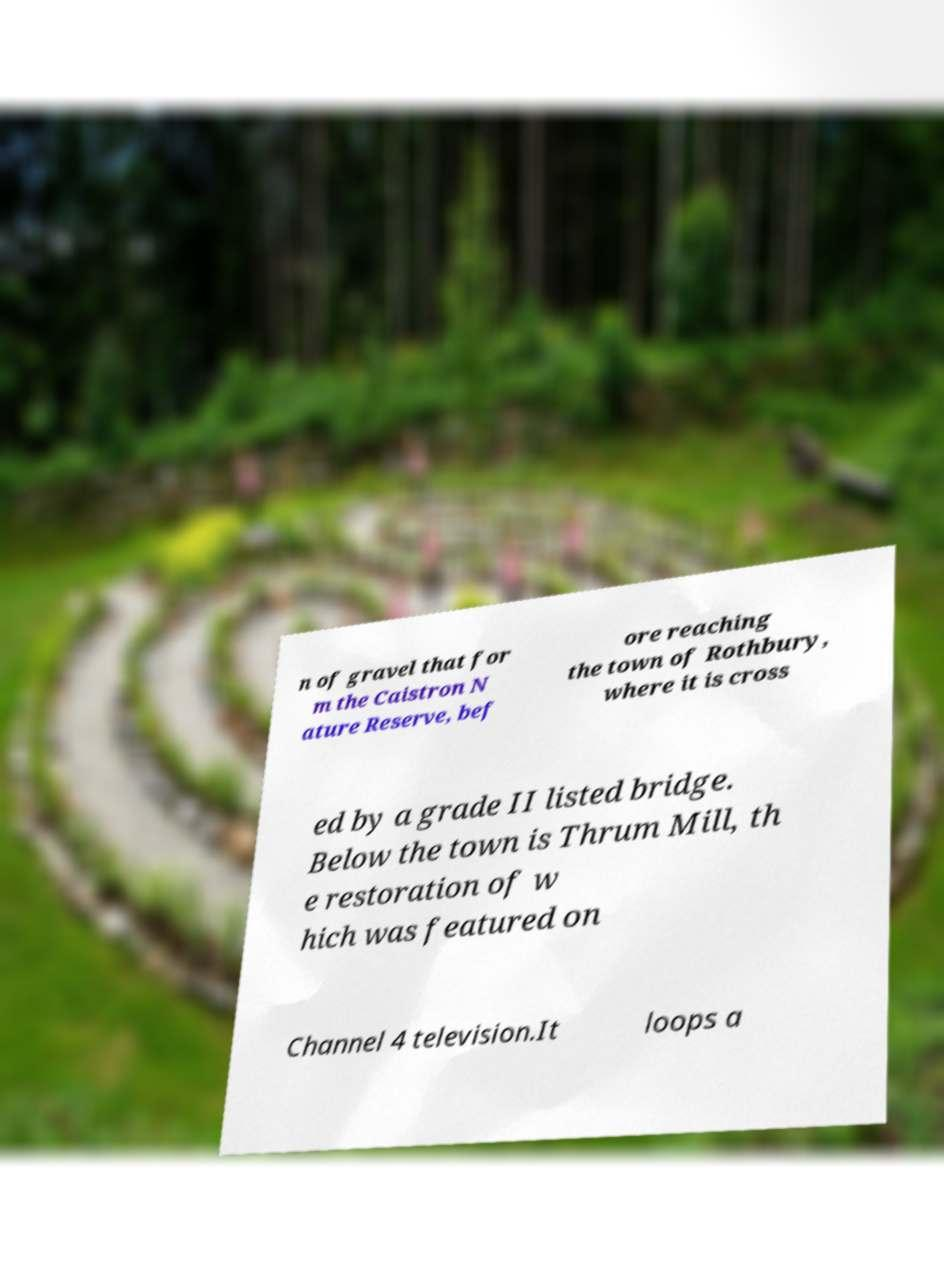There's text embedded in this image that I need extracted. Can you transcribe it verbatim? n of gravel that for m the Caistron N ature Reserve, bef ore reaching the town of Rothbury, where it is cross ed by a grade II listed bridge. Below the town is Thrum Mill, th e restoration of w hich was featured on Channel 4 television.It loops a 